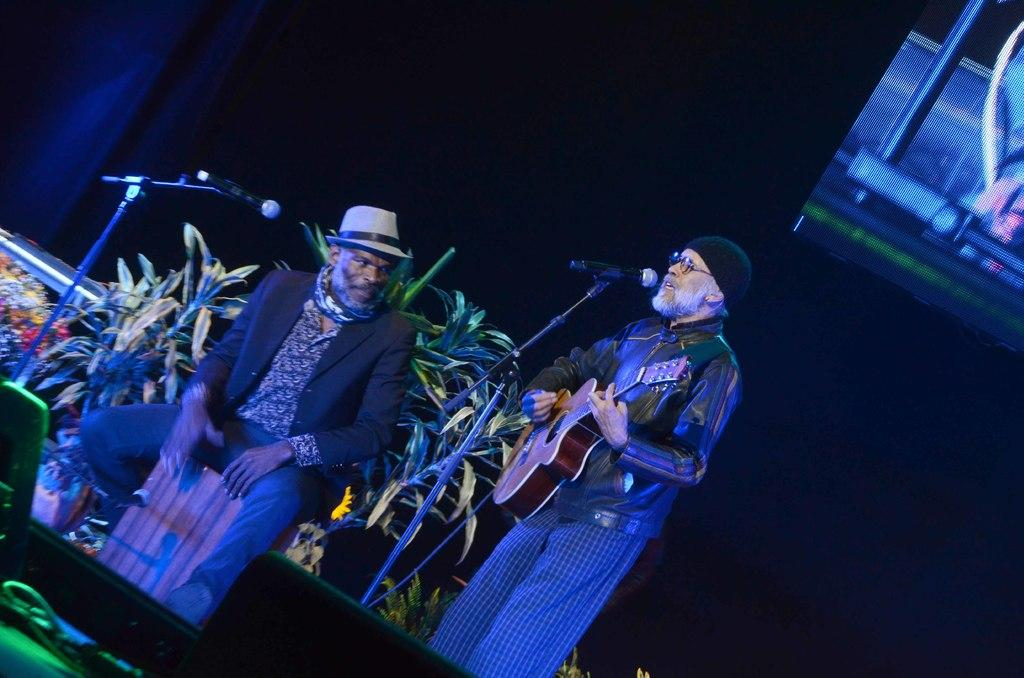How many people are in the image? There are two persons in the image. What are the persons doing in the image? The persons are near a microphone. What can be seen in the background of the image? There are plants in the background of the image. Can you tell me how deep the river is in the image? There is no river present in the image. What type of education is the toad receiving in the image? There is no toad present in the image, and therefore no education can be observed. 